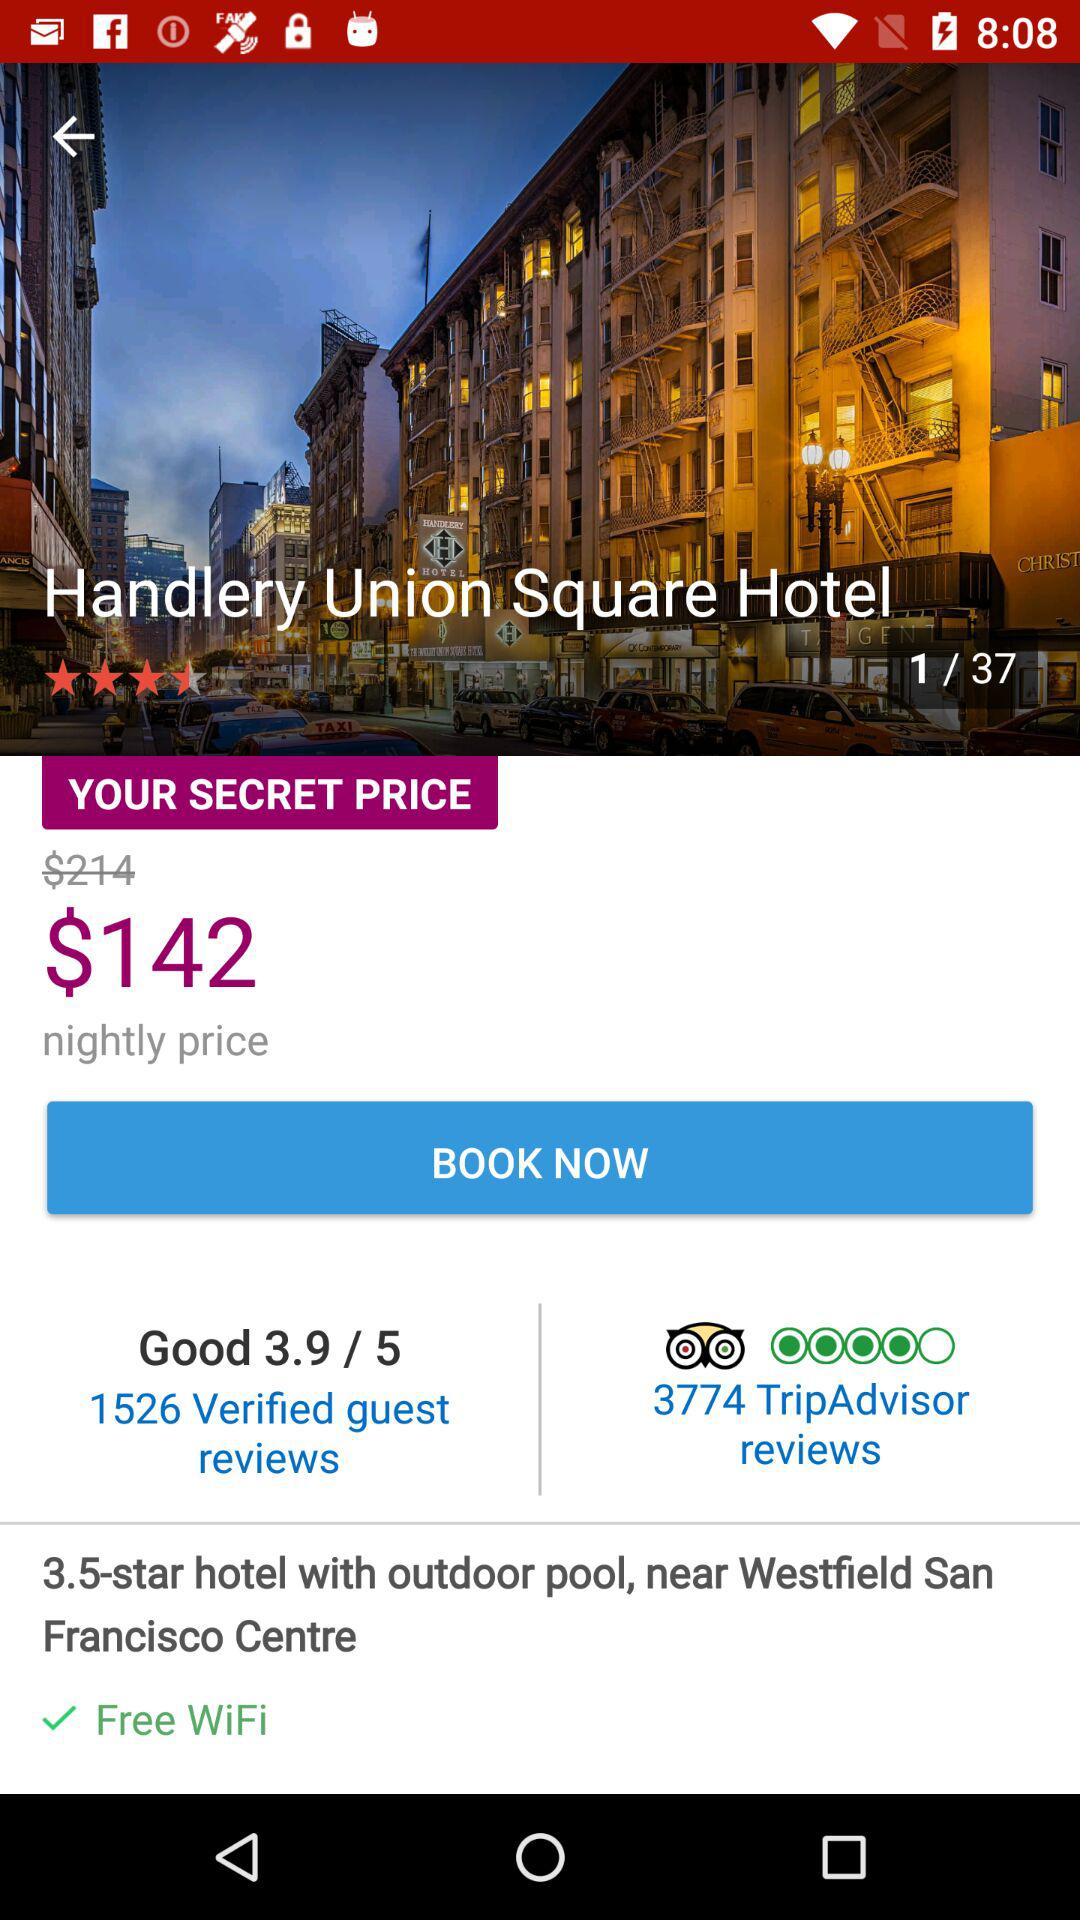What is the mentioned location?
When the provided information is insufficient, respond with <no answer>. <no answer> 